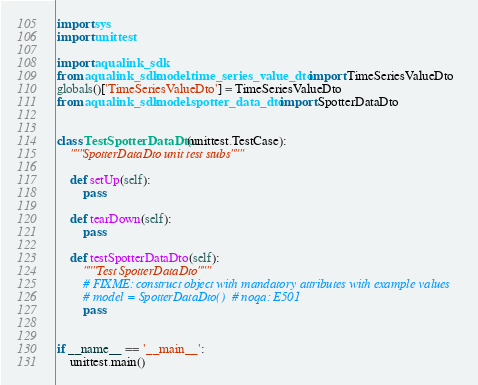Convert code to text. <code><loc_0><loc_0><loc_500><loc_500><_Python_>

import sys
import unittest

import aqualink_sdk
from aqualink_sdk.model.time_series_value_dto import TimeSeriesValueDto
globals()['TimeSeriesValueDto'] = TimeSeriesValueDto
from aqualink_sdk.model.spotter_data_dto import SpotterDataDto


class TestSpotterDataDto(unittest.TestCase):
    """SpotterDataDto unit test stubs"""

    def setUp(self):
        pass

    def tearDown(self):
        pass

    def testSpotterDataDto(self):
        """Test SpotterDataDto"""
        # FIXME: construct object with mandatory attributes with example values
        # model = SpotterDataDto()  # noqa: E501
        pass


if __name__ == '__main__':
    unittest.main()
</code> 